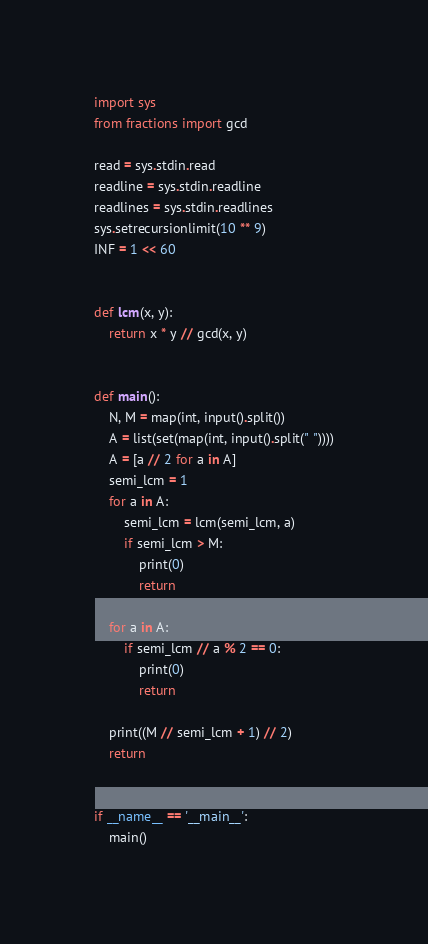<code> <loc_0><loc_0><loc_500><loc_500><_Python_>import sys
from fractions import gcd

read = sys.stdin.read
readline = sys.stdin.readline
readlines = sys.stdin.readlines
sys.setrecursionlimit(10 ** 9)
INF = 1 << 60


def lcm(x, y):
    return x * y // gcd(x, y)


def main():
    N, M = map(int, input().split())
    A = list(set(map(int, input().split(" "))))
    A = [a // 2 for a in A]
    semi_lcm = 1
    for a in A:
        semi_lcm = lcm(semi_lcm, a)
        if semi_lcm > M:
            print(0)
            return

    for a in A:
        if semi_lcm // a % 2 == 0:
            print(0)
            return

    print((M // semi_lcm + 1) // 2)
    return


if __name__ == '__main__':
    main()
</code> 